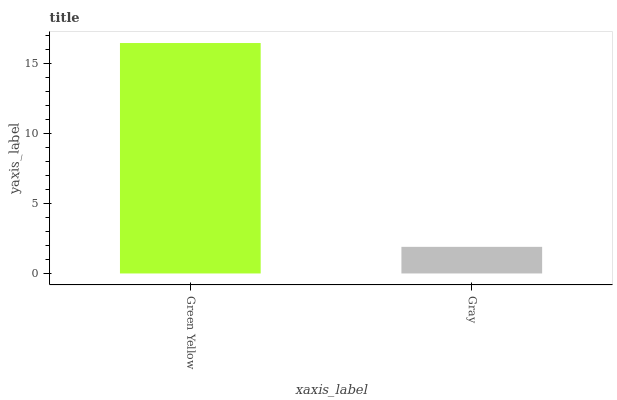Is Gray the minimum?
Answer yes or no. Yes. Is Green Yellow the maximum?
Answer yes or no. Yes. Is Gray the maximum?
Answer yes or no. No. Is Green Yellow greater than Gray?
Answer yes or no. Yes. Is Gray less than Green Yellow?
Answer yes or no. Yes. Is Gray greater than Green Yellow?
Answer yes or no. No. Is Green Yellow less than Gray?
Answer yes or no. No. Is Green Yellow the high median?
Answer yes or no. Yes. Is Gray the low median?
Answer yes or no. Yes. Is Gray the high median?
Answer yes or no. No. Is Green Yellow the low median?
Answer yes or no. No. 